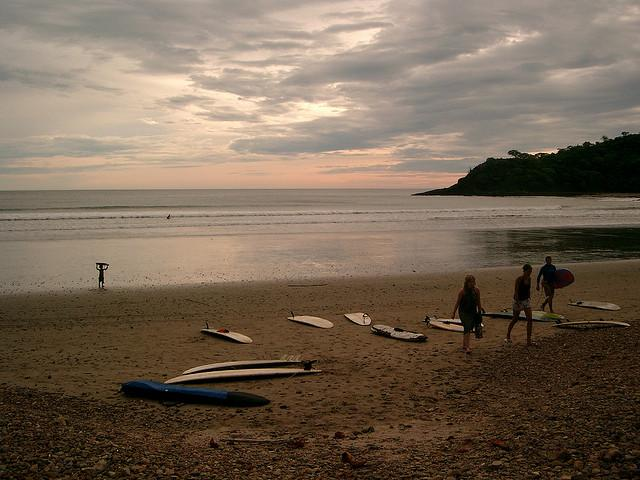Why is he carrying his surfboard? Please explain your reasoning. done surfing. By the time of day and the direction is facing suggests they are done for the day. 